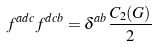<formula> <loc_0><loc_0><loc_500><loc_500>f ^ { a d c } f ^ { d c b } = \delta ^ { a b } \frac { C _ { 2 } ( G ) } { 2 }</formula> 